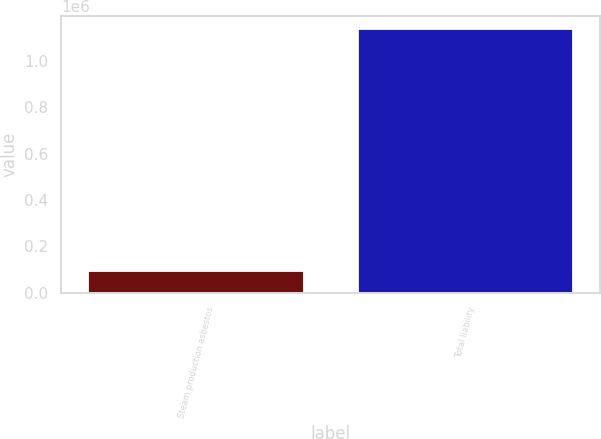Convert chart to OTSL. <chart><loc_0><loc_0><loc_500><loc_500><bar_chart><fcel>Steam production asbestos<fcel>Total liability<nl><fcel>93141<fcel>1.13518e+06<nl></chart> 